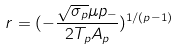Convert formula to latex. <formula><loc_0><loc_0><loc_500><loc_500>r = ( - \frac { \sqrt { \sigma _ { p } } \mu p _ { - } } { 2 T _ { p } A _ { p } } ) ^ { 1 / ( p - 1 ) }</formula> 